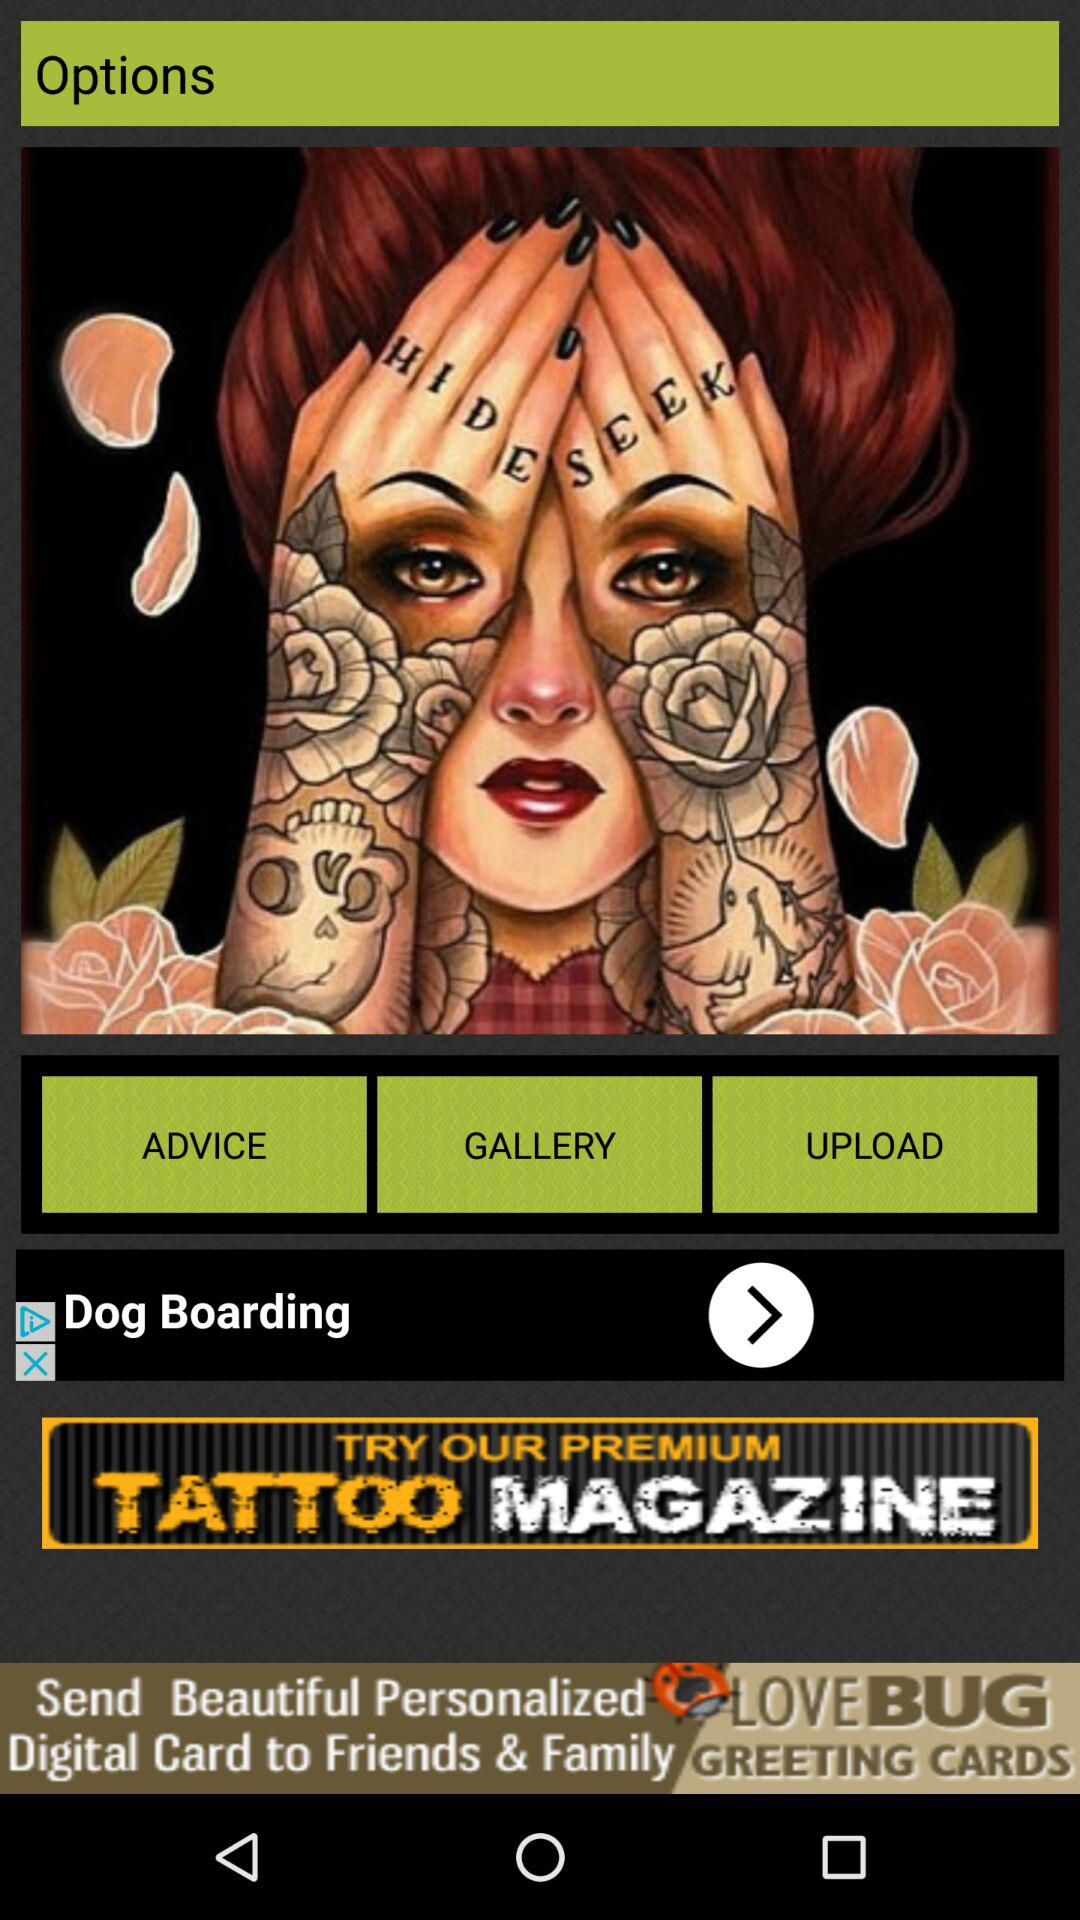What is the application name? The application name is "TATTOO MAGAZINE". 